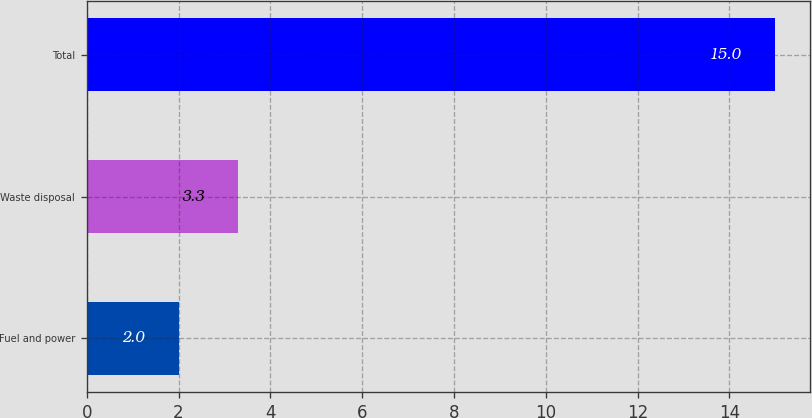Convert chart. <chart><loc_0><loc_0><loc_500><loc_500><bar_chart><fcel>Fuel and power<fcel>Waste disposal<fcel>Total<nl><fcel>2<fcel>3.3<fcel>15<nl></chart> 